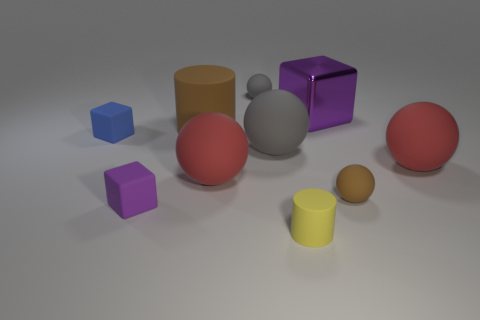Subtract all brown spheres. How many spheres are left? 4 Subtract all brown spheres. How many spheres are left? 4 Subtract all cyan balls. Subtract all green cylinders. How many balls are left? 5 Subtract all blocks. How many objects are left? 7 Add 5 blue objects. How many blue objects exist? 6 Subtract 1 yellow cylinders. How many objects are left? 9 Subtract all big things. Subtract all tiny gray matte blocks. How many objects are left? 5 Add 1 tiny blue rubber objects. How many tiny blue rubber objects are left? 2 